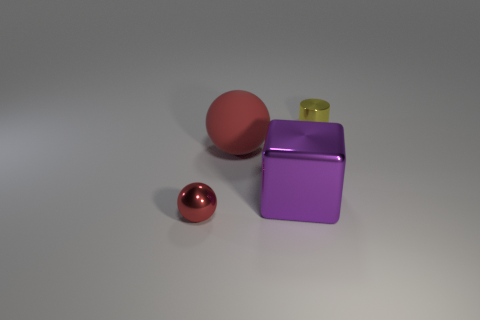There is a metal thing that is the same color as the matte sphere; what is its size? The metal object sharing the same color as the matte sphere appears to be small in size, likely no larger than a few inches in diameter, comparable to a table tennis ball. It reflects light and has a distinctive shine indicative of a metallic surface. 